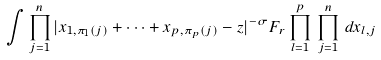Convert formula to latex. <formula><loc_0><loc_0><loc_500><loc_500>\int \prod _ { j = 1 } ^ { n } { | x _ { 1 , \pi _ { 1 } ( j ) } + \cdots + x _ { p , \pi _ { p } ( j ) } - z | ^ { - \sigma } } F _ { r } \prod _ { l = 1 } ^ { p } \, \prod _ { j = 1 } ^ { n } \, d x _ { l , j }</formula> 